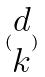<formula> <loc_0><loc_0><loc_500><loc_500>( \begin{matrix} d \\ k \end{matrix} )</formula> 